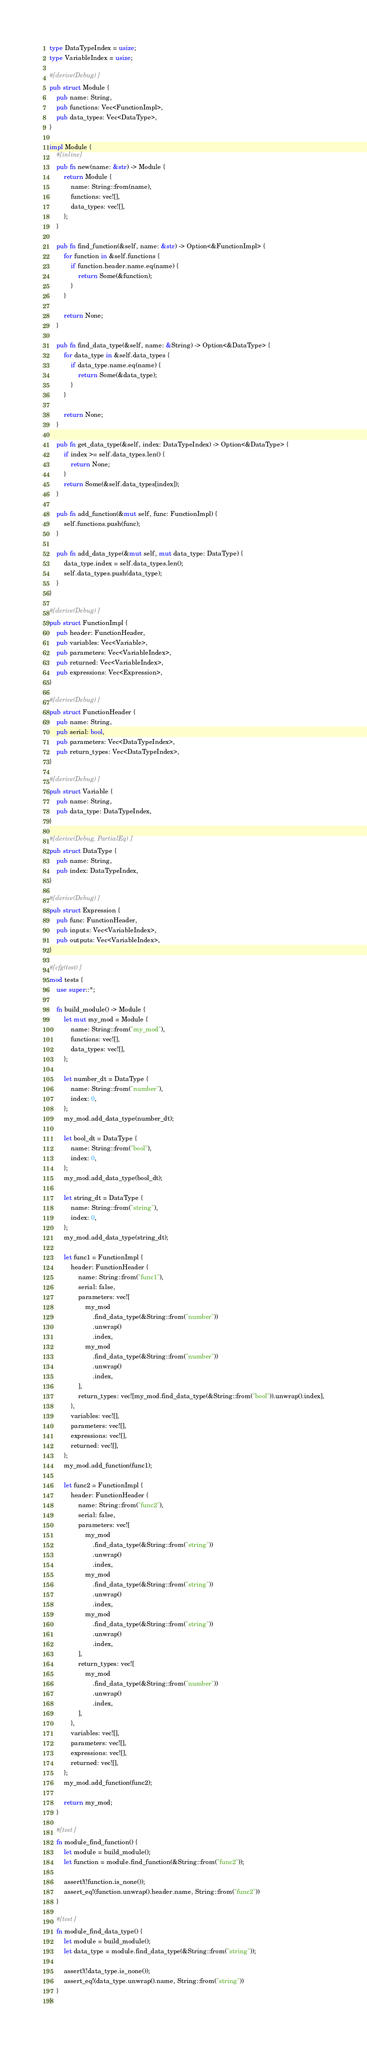<code> <loc_0><loc_0><loc_500><loc_500><_Rust_>type DataTypeIndex = usize;
type VariableIndex = usize;

#[derive(Debug)]
pub struct Module {
    pub name: String,
    pub functions: Vec<FunctionImpl>,
    pub data_types: Vec<DataType>,
}

impl Module {
    #[inline]
    pub fn new(name: &str) -> Module {
        return Module {
            name: String::from(name),
            functions: vec![],
            data_types: vec![],
        };
    }

    pub fn find_function(&self, name: &str) -> Option<&FunctionImpl> {
        for function in &self.functions {
            if function.header.name.eq(name) {
                return Some(&function);
            }
        }

        return None;
    }

    pub fn find_data_type(&self, name: &String) -> Option<&DataType> {
        for data_type in &self.data_types {
            if data_type.name.eq(name) {
                return Some(&data_type);
            }
        }

        return None;
    }

    pub fn get_data_type(&self, index: DataTypeIndex) -> Option<&DataType> {
        if index >= self.data_types.len() {
            return None;
        }
        return Some(&self.data_types[index]);
    }

    pub fn add_function(&mut self, func: FunctionImpl) {
        self.functions.push(func);
    }

    pub fn add_data_type(&mut self, mut data_type: DataType) {
        data_type.index = self.data_types.len();
        self.data_types.push(data_type);
    }
}

#[derive(Debug)]
pub struct FunctionImpl {
    pub header: FunctionHeader,
    pub variables: Vec<Variable>,
    pub parameters: Vec<VariableIndex>,
    pub returned: Vec<VariableIndex>,
    pub expressions: Vec<Expression>,
}

#[derive(Debug)]
pub struct FunctionHeader {
    pub name: String,
    pub serial: bool,
    pub parameters: Vec<DataTypeIndex>,
    pub return_types: Vec<DataTypeIndex>,
}

#[derive(Debug)]
pub struct Variable {
    pub name: String,
    pub data_type: DataTypeIndex,
}

#[derive(Debug, PartialEq)]
pub struct DataType {
    pub name: String,
    pub index: DataTypeIndex,
}

#[derive(Debug)]
pub struct Expression {
    pub func: FunctionHeader,
    pub inputs: Vec<VariableIndex>,
    pub outputs: Vec<VariableIndex>,
}

#[cfg(test)]
mod tests {
    use super::*;

    fn build_module() -> Module {
        let mut my_mod = Module {
            name: String::from("my_mod"),
            functions: vec![],
            data_types: vec![],
        };

        let number_dt = DataType {
            name: String::from("number"),
            index: 0,
        };
        my_mod.add_data_type(number_dt);

        let bool_dt = DataType {
            name: String::from("bool"),
            index: 0,
        };
        my_mod.add_data_type(bool_dt);

        let string_dt = DataType {
            name: String::from("string"),
            index: 0,
        };
        my_mod.add_data_type(string_dt);

        let func1 = FunctionImpl {
            header: FunctionHeader {
                name: String::from("func1"),
                serial: false,
                parameters: vec![
                    my_mod
                        .find_data_type(&String::from("number"))
                        .unwrap()
                        .index,
                    my_mod
                        .find_data_type(&String::from("number"))
                        .unwrap()
                        .index,
                ],
                return_types: vec![my_mod.find_data_type(&String::from("bool")).unwrap().index],
            },
            variables: vec![],
            parameters: vec![],
            expressions: vec![],
            returned: vec![],
        };
        my_mod.add_function(func1);

        let func2 = FunctionImpl {
            header: FunctionHeader {
                name: String::from("func2"),
                serial: false,
                parameters: vec![
                    my_mod
                        .find_data_type(&String::from("string"))
                        .unwrap()
                        .index,
                    my_mod
                        .find_data_type(&String::from("string"))
                        .unwrap()
                        .index,
                    my_mod
                        .find_data_type(&String::from("string"))
                        .unwrap()
                        .index,
                ],
                return_types: vec![
                    my_mod
                        .find_data_type(&String::from("number"))
                        .unwrap()
                        .index,
                ],
            },
            variables: vec![],
            parameters: vec![],
            expressions: vec![],
            returned: vec![],
        };
        my_mod.add_function(func2);

        return my_mod;
    }

    #[test]
    fn module_find_function() {
        let module = build_module();
        let function = module.find_function(&String::from("func2"));

        assert!(!function.is_none());
        assert_eq!(function.unwrap().header.name, String::from("func2"))
    }

    #[test]
    fn module_find_data_type() {
        let module = build_module();
        let data_type = module.find_data_type(&String::from("string"));

        assert!(!data_type.is_none());
        assert_eq!(data_type.unwrap().name, String::from("string"))
    }
}
</code> 